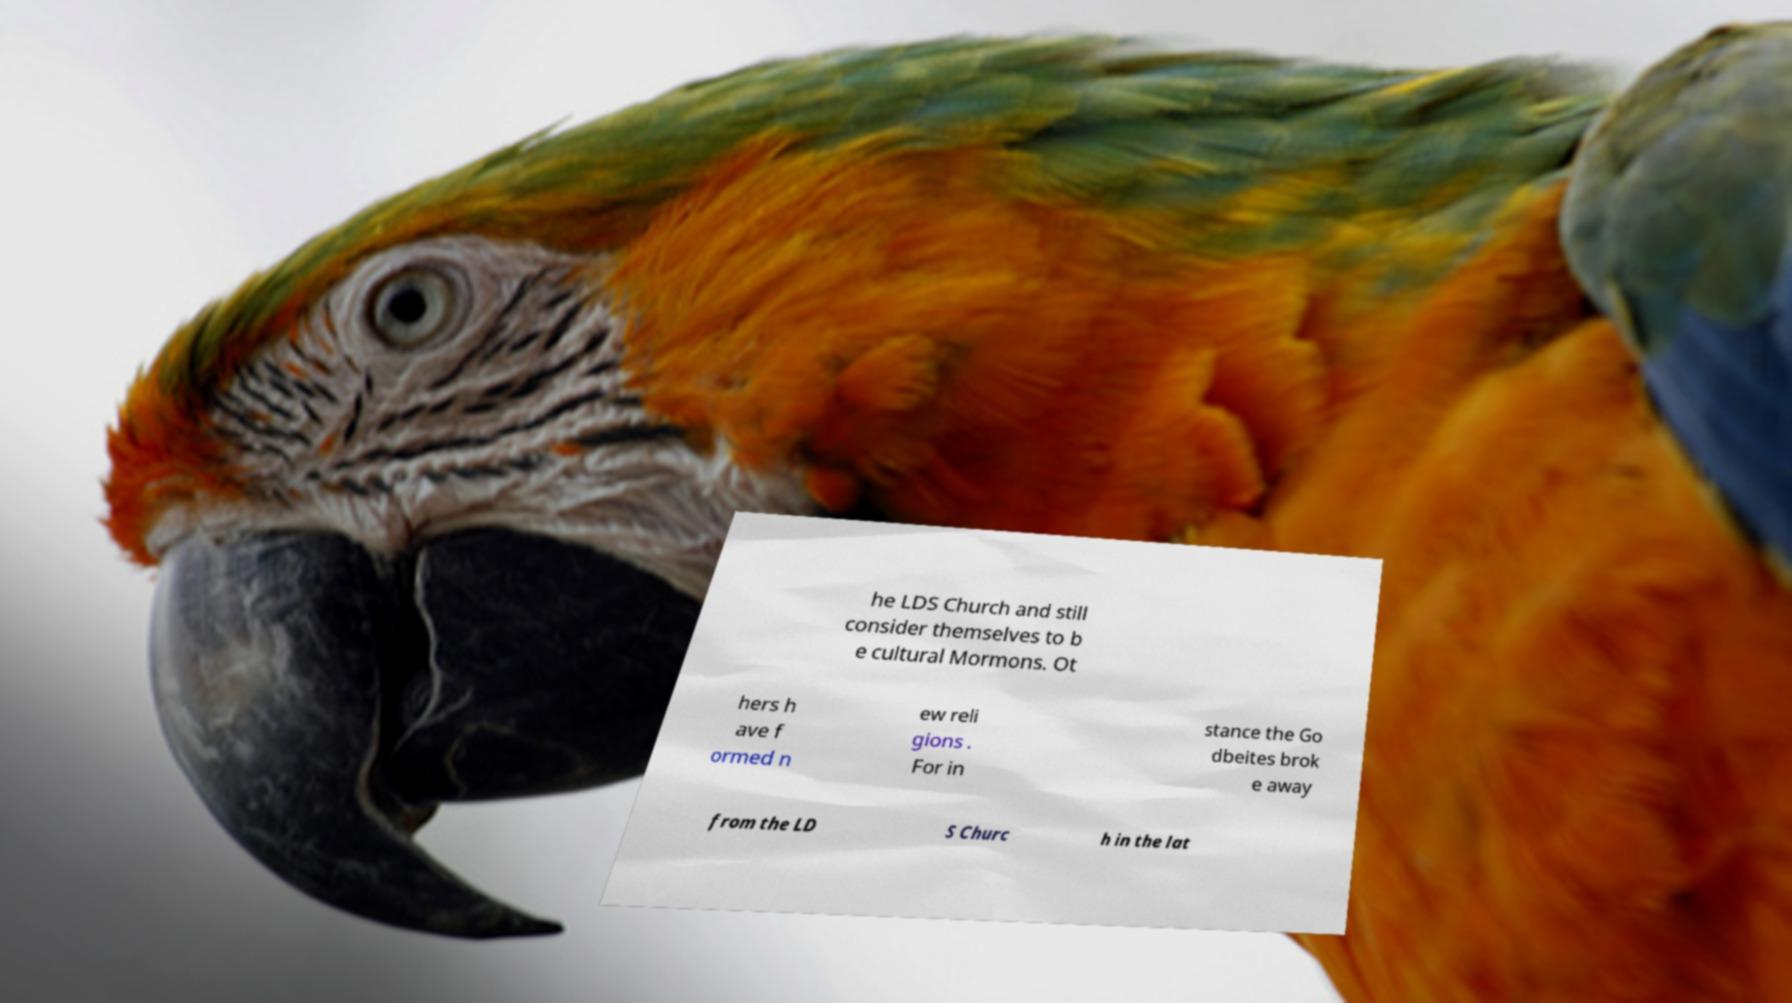Please identify and transcribe the text found in this image. he LDS Church and still consider themselves to b e cultural Mormons. Ot hers h ave f ormed n ew reli gions . For in stance the Go dbeites brok e away from the LD S Churc h in the lat 